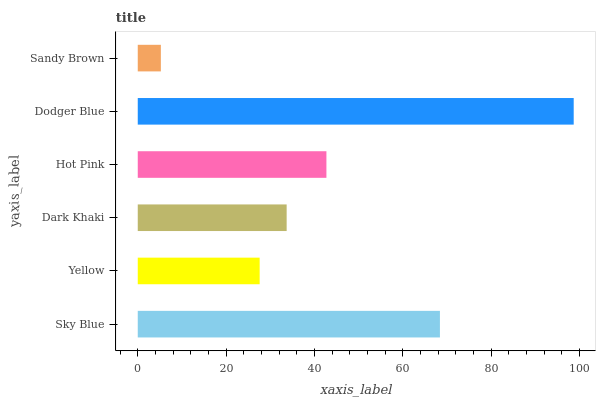Is Sandy Brown the minimum?
Answer yes or no. Yes. Is Dodger Blue the maximum?
Answer yes or no. Yes. Is Yellow the minimum?
Answer yes or no. No. Is Yellow the maximum?
Answer yes or no. No. Is Sky Blue greater than Yellow?
Answer yes or no. Yes. Is Yellow less than Sky Blue?
Answer yes or no. Yes. Is Yellow greater than Sky Blue?
Answer yes or no. No. Is Sky Blue less than Yellow?
Answer yes or no. No. Is Hot Pink the high median?
Answer yes or no. Yes. Is Dark Khaki the low median?
Answer yes or no. Yes. Is Sandy Brown the high median?
Answer yes or no. No. Is Dodger Blue the low median?
Answer yes or no. No. 